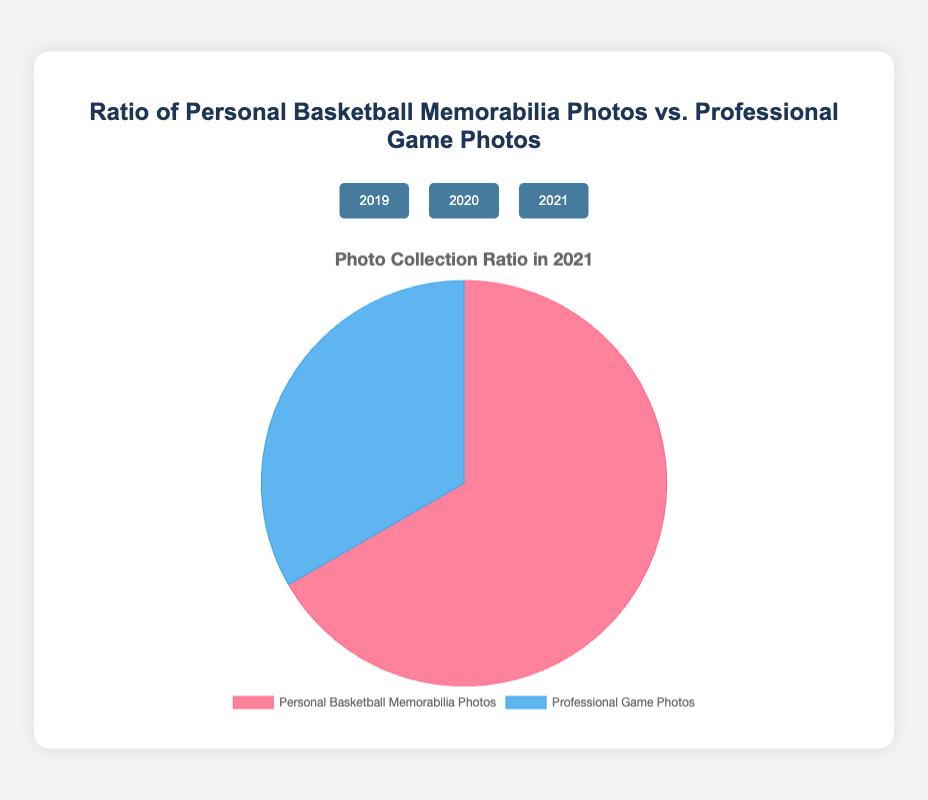What percentage of the photos were labeled as "Personal Basketball Memorabilia Photos" in 2021? First, we refer to the pie chart for the year 2021. We know that the total number of photos is the sum of Personal Basketball Memorabilia Photos and Professional Game Photos (300 + 150 = 450). The percentage of Personal Basketball Memorabilia Photos is (300/450) * 100 = 66.67%.
Answer: 66.67% Which category had more photos in 2020, Personal Basketball Memorabilia Photos or Professional Game Photos? We look at the values for 2020. Personal Basketball Memorabilia Photos had 280 photos, while Professional Game Photos had 200 photos. Since 280 is greater than 200, Personal Basketball Memorabilia Photos had more photos.
Answer: Personal Basketball Memorabilia Photos In 2019, what is the ratio of Personal Basketball Memorabilia Photos to Professional Game Photos? We find the values for 2019. Personal Basketball Memorabilia Photos had 320 photos and Professional Game Photos had 180 photos. The ratio is calculated as 320:180, which simplifies to 16:9.
Answer: 16:9 What is the total number of photos taken in all three years combined? We sum the total number of photos for each year. In 2019, there are 320 + 180 = 500 photos; in 2020, there are 280 + 200 = 480 photos; in 2021, there are 300 + 150 = 450 photos. The combined total is 500 + 480 + 450 = 1430 photos.
Answer: 1430 Which year had the highest ratio of Personal Basketball Memorabilia Photos to Professional Game Photos? We calculate the ratio for each year. In 2019, the ratio is 320/180 = 1.78; in 2020, it is 280/200 = 1.40; in 2021, it is 300/150 = 2.00. The highest ratio is in 2021.
Answer: 2021 How did the total number of Professional Game Photos change from 2019 to 2020? We refer to the values for Professional Game Photos in 2019 and 2020. In 2019, there were 180 photos. In 2020, there were 200 photos. The change is calculated as 200 - 180 = 20 photos. Thus, it increased by 20 photos.
Answer: Increased by 20 What is the average number of Personal Basketball Memorabilia Photos taken per year? We calculate the total number of Personal Basketball Memorabilia Photos over all three years, which is 320 + 280 + 300 = 900. Since there are three years, the average is 900/3 = 300 photos per year.
Answer: 300 